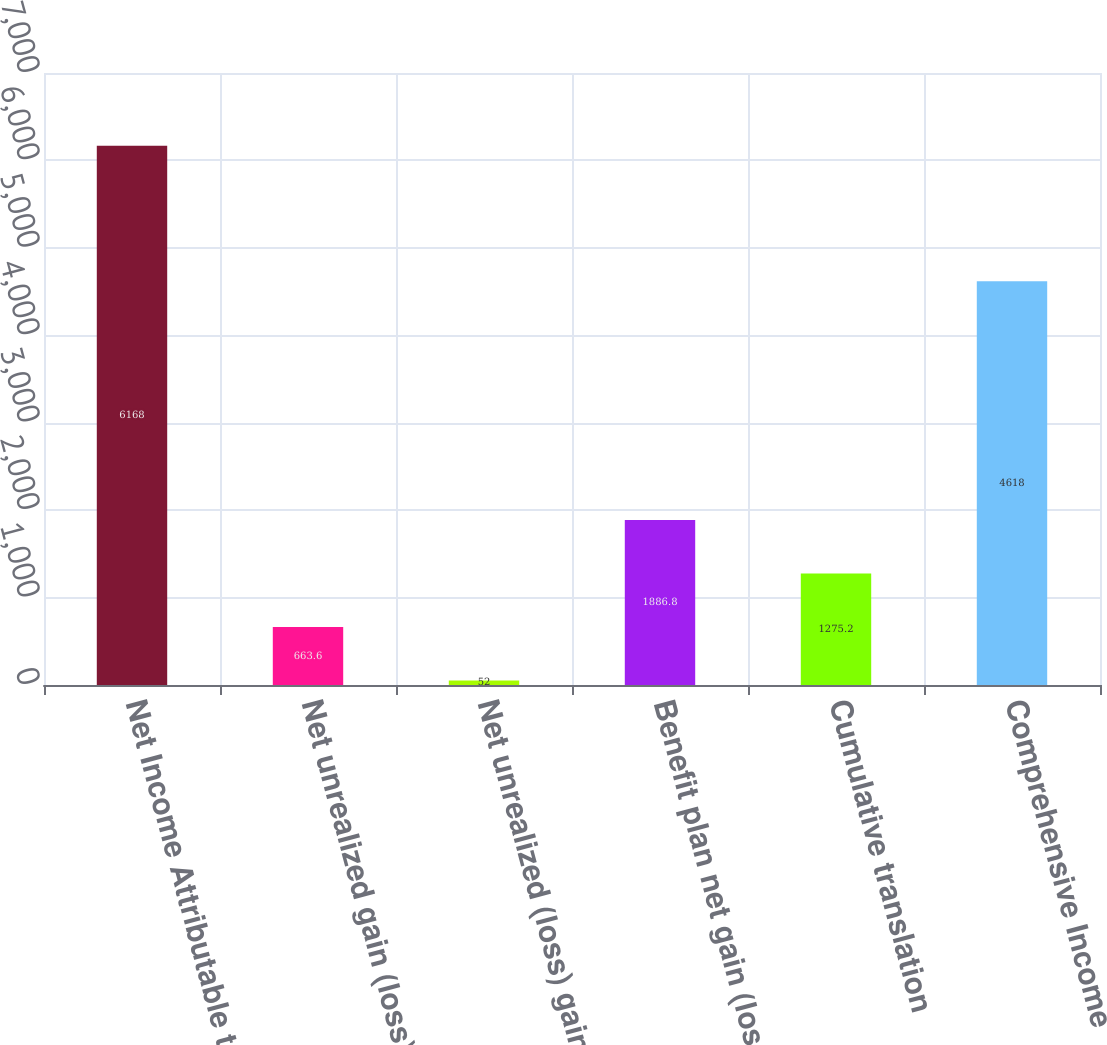Convert chart. <chart><loc_0><loc_0><loc_500><loc_500><bar_chart><fcel>Net Income Attributable to<fcel>Net unrealized gain (loss) on<fcel>Net unrealized (loss) gain on<fcel>Benefit plan net gain (loss)<fcel>Cumulative translation<fcel>Comprehensive Income<nl><fcel>6168<fcel>663.6<fcel>52<fcel>1886.8<fcel>1275.2<fcel>4618<nl></chart> 